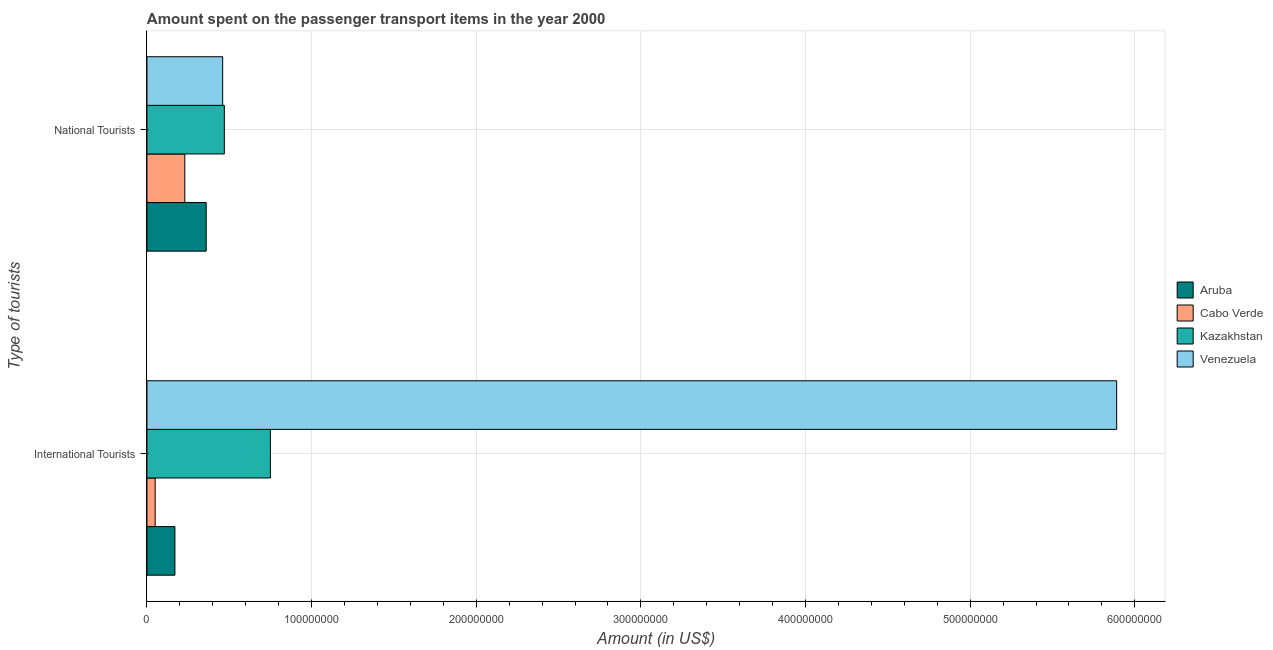How many different coloured bars are there?
Your answer should be compact. 4. Are the number of bars on each tick of the Y-axis equal?
Ensure brevity in your answer.  Yes. What is the label of the 2nd group of bars from the top?
Keep it short and to the point. International Tourists. What is the amount spent on transport items of national tourists in Kazakhstan?
Ensure brevity in your answer.  4.70e+07. Across all countries, what is the maximum amount spent on transport items of national tourists?
Your answer should be very brief. 4.70e+07. Across all countries, what is the minimum amount spent on transport items of international tourists?
Keep it short and to the point. 5.00e+06. In which country was the amount spent on transport items of national tourists maximum?
Ensure brevity in your answer.  Kazakhstan. In which country was the amount spent on transport items of national tourists minimum?
Your response must be concise. Cabo Verde. What is the total amount spent on transport items of international tourists in the graph?
Give a very brief answer. 6.86e+08. What is the difference between the amount spent on transport items of national tourists in Cabo Verde and that in Venezuela?
Provide a succinct answer. -2.30e+07. What is the difference between the amount spent on transport items of international tourists in Aruba and the amount spent on transport items of national tourists in Cabo Verde?
Ensure brevity in your answer.  -6.00e+06. What is the average amount spent on transport items of national tourists per country?
Offer a terse response. 3.80e+07. What is the difference between the amount spent on transport items of international tourists and amount spent on transport items of national tourists in Kazakhstan?
Keep it short and to the point. 2.80e+07. In how many countries, is the amount spent on transport items of national tourists greater than 40000000 US$?
Provide a succinct answer. 2. What is the ratio of the amount spent on transport items of national tourists in Aruba to that in Cabo Verde?
Your answer should be very brief. 1.57. In how many countries, is the amount spent on transport items of national tourists greater than the average amount spent on transport items of national tourists taken over all countries?
Keep it short and to the point. 2. What does the 2nd bar from the top in National Tourists represents?
Make the answer very short. Kazakhstan. What does the 1st bar from the bottom in National Tourists represents?
Ensure brevity in your answer.  Aruba. How many bars are there?
Your answer should be very brief. 8. Are all the bars in the graph horizontal?
Offer a terse response. Yes. How many countries are there in the graph?
Give a very brief answer. 4. Does the graph contain grids?
Ensure brevity in your answer.  Yes. Where does the legend appear in the graph?
Provide a short and direct response. Center right. What is the title of the graph?
Offer a very short reply. Amount spent on the passenger transport items in the year 2000. Does "St. Lucia" appear as one of the legend labels in the graph?
Ensure brevity in your answer.  No. What is the label or title of the Y-axis?
Provide a short and direct response. Type of tourists. What is the Amount (in US$) in Aruba in International Tourists?
Make the answer very short. 1.70e+07. What is the Amount (in US$) in Kazakhstan in International Tourists?
Offer a terse response. 7.50e+07. What is the Amount (in US$) in Venezuela in International Tourists?
Make the answer very short. 5.89e+08. What is the Amount (in US$) of Aruba in National Tourists?
Your response must be concise. 3.60e+07. What is the Amount (in US$) in Cabo Verde in National Tourists?
Give a very brief answer. 2.30e+07. What is the Amount (in US$) in Kazakhstan in National Tourists?
Ensure brevity in your answer.  4.70e+07. What is the Amount (in US$) of Venezuela in National Tourists?
Provide a succinct answer. 4.60e+07. Across all Type of tourists, what is the maximum Amount (in US$) of Aruba?
Provide a succinct answer. 3.60e+07. Across all Type of tourists, what is the maximum Amount (in US$) in Cabo Verde?
Ensure brevity in your answer.  2.30e+07. Across all Type of tourists, what is the maximum Amount (in US$) of Kazakhstan?
Provide a short and direct response. 7.50e+07. Across all Type of tourists, what is the maximum Amount (in US$) in Venezuela?
Ensure brevity in your answer.  5.89e+08. Across all Type of tourists, what is the minimum Amount (in US$) in Aruba?
Your answer should be very brief. 1.70e+07. Across all Type of tourists, what is the minimum Amount (in US$) in Kazakhstan?
Offer a terse response. 4.70e+07. Across all Type of tourists, what is the minimum Amount (in US$) in Venezuela?
Your response must be concise. 4.60e+07. What is the total Amount (in US$) in Aruba in the graph?
Ensure brevity in your answer.  5.30e+07. What is the total Amount (in US$) of Cabo Verde in the graph?
Offer a terse response. 2.80e+07. What is the total Amount (in US$) of Kazakhstan in the graph?
Give a very brief answer. 1.22e+08. What is the total Amount (in US$) of Venezuela in the graph?
Your answer should be compact. 6.35e+08. What is the difference between the Amount (in US$) in Aruba in International Tourists and that in National Tourists?
Ensure brevity in your answer.  -1.90e+07. What is the difference between the Amount (in US$) of Cabo Verde in International Tourists and that in National Tourists?
Offer a very short reply. -1.80e+07. What is the difference between the Amount (in US$) of Kazakhstan in International Tourists and that in National Tourists?
Make the answer very short. 2.80e+07. What is the difference between the Amount (in US$) of Venezuela in International Tourists and that in National Tourists?
Your response must be concise. 5.43e+08. What is the difference between the Amount (in US$) in Aruba in International Tourists and the Amount (in US$) in Cabo Verde in National Tourists?
Offer a terse response. -6.00e+06. What is the difference between the Amount (in US$) in Aruba in International Tourists and the Amount (in US$) in Kazakhstan in National Tourists?
Provide a succinct answer. -3.00e+07. What is the difference between the Amount (in US$) of Aruba in International Tourists and the Amount (in US$) of Venezuela in National Tourists?
Your response must be concise. -2.90e+07. What is the difference between the Amount (in US$) in Cabo Verde in International Tourists and the Amount (in US$) in Kazakhstan in National Tourists?
Offer a terse response. -4.20e+07. What is the difference between the Amount (in US$) of Cabo Verde in International Tourists and the Amount (in US$) of Venezuela in National Tourists?
Your response must be concise. -4.10e+07. What is the difference between the Amount (in US$) in Kazakhstan in International Tourists and the Amount (in US$) in Venezuela in National Tourists?
Provide a succinct answer. 2.90e+07. What is the average Amount (in US$) of Aruba per Type of tourists?
Provide a succinct answer. 2.65e+07. What is the average Amount (in US$) in Cabo Verde per Type of tourists?
Provide a short and direct response. 1.40e+07. What is the average Amount (in US$) in Kazakhstan per Type of tourists?
Keep it short and to the point. 6.10e+07. What is the average Amount (in US$) in Venezuela per Type of tourists?
Your answer should be very brief. 3.18e+08. What is the difference between the Amount (in US$) in Aruba and Amount (in US$) in Cabo Verde in International Tourists?
Provide a short and direct response. 1.20e+07. What is the difference between the Amount (in US$) of Aruba and Amount (in US$) of Kazakhstan in International Tourists?
Your answer should be very brief. -5.80e+07. What is the difference between the Amount (in US$) in Aruba and Amount (in US$) in Venezuela in International Tourists?
Your answer should be very brief. -5.72e+08. What is the difference between the Amount (in US$) in Cabo Verde and Amount (in US$) in Kazakhstan in International Tourists?
Make the answer very short. -7.00e+07. What is the difference between the Amount (in US$) of Cabo Verde and Amount (in US$) of Venezuela in International Tourists?
Your response must be concise. -5.84e+08. What is the difference between the Amount (in US$) in Kazakhstan and Amount (in US$) in Venezuela in International Tourists?
Your answer should be compact. -5.14e+08. What is the difference between the Amount (in US$) of Aruba and Amount (in US$) of Cabo Verde in National Tourists?
Offer a terse response. 1.30e+07. What is the difference between the Amount (in US$) in Aruba and Amount (in US$) in Kazakhstan in National Tourists?
Offer a very short reply. -1.10e+07. What is the difference between the Amount (in US$) in Aruba and Amount (in US$) in Venezuela in National Tourists?
Your response must be concise. -1.00e+07. What is the difference between the Amount (in US$) in Cabo Verde and Amount (in US$) in Kazakhstan in National Tourists?
Your answer should be very brief. -2.40e+07. What is the difference between the Amount (in US$) of Cabo Verde and Amount (in US$) of Venezuela in National Tourists?
Your answer should be very brief. -2.30e+07. What is the ratio of the Amount (in US$) in Aruba in International Tourists to that in National Tourists?
Give a very brief answer. 0.47. What is the ratio of the Amount (in US$) of Cabo Verde in International Tourists to that in National Tourists?
Offer a very short reply. 0.22. What is the ratio of the Amount (in US$) in Kazakhstan in International Tourists to that in National Tourists?
Your answer should be very brief. 1.6. What is the ratio of the Amount (in US$) of Venezuela in International Tourists to that in National Tourists?
Offer a terse response. 12.8. What is the difference between the highest and the second highest Amount (in US$) of Aruba?
Your answer should be very brief. 1.90e+07. What is the difference between the highest and the second highest Amount (in US$) of Cabo Verde?
Make the answer very short. 1.80e+07. What is the difference between the highest and the second highest Amount (in US$) in Kazakhstan?
Your response must be concise. 2.80e+07. What is the difference between the highest and the second highest Amount (in US$) in Venezuela?
Offer a very short reply. 5.43e+08. What is the difference between the highest and the lowest Amount (in US$) in Aruba?
Keep it short and to the point. 1.90e+07. What is the difference between the highest and the lowest Amount (in US$) of Cabo Verde?
Ensure brevity in your answer.  1.80e+07. What is the difference between the highest and the lowest Amount (in US$) in Kazakhstan?
Keep it short and to the point. 2.80e+07. What is the difference between the highest and the lowest Amount (in US$) of Venezuela?
Your answer should be compact. 5.43e+08. 